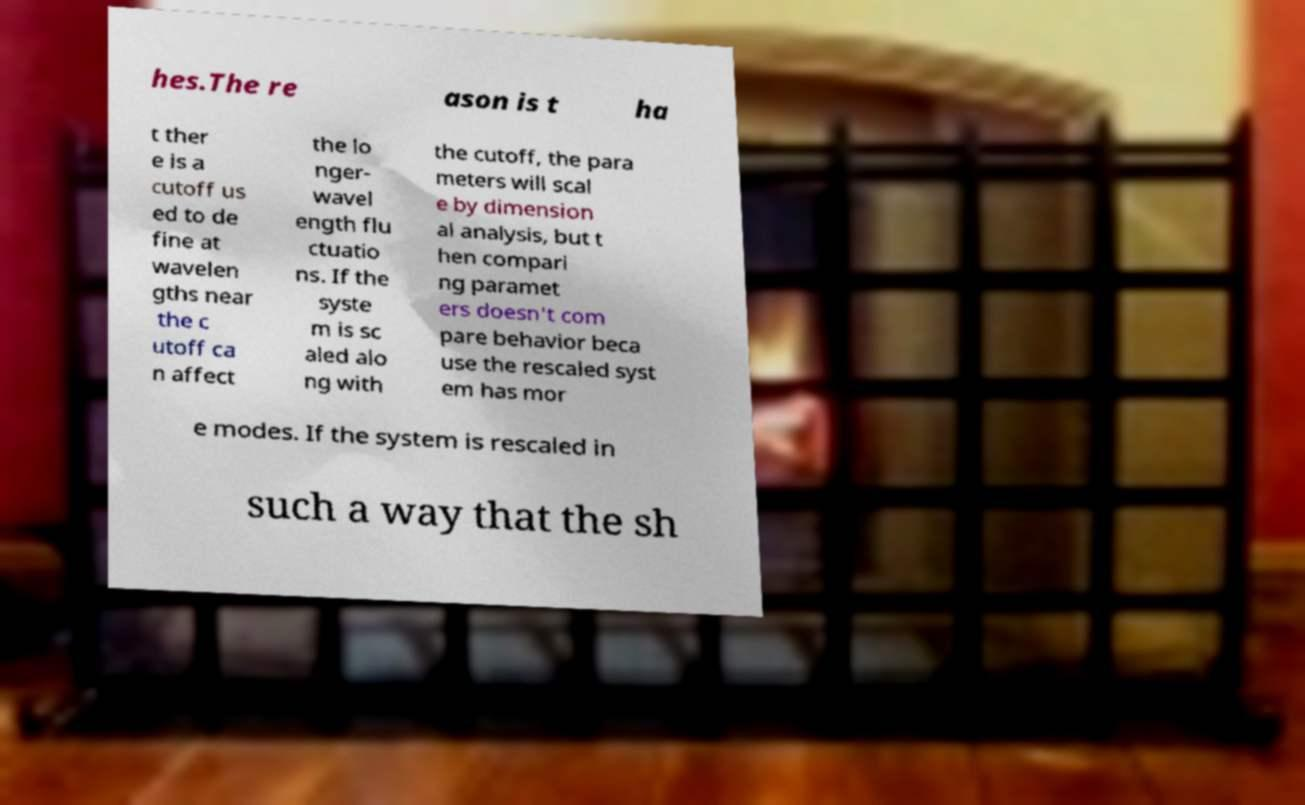Please read and relay the text visible in this image. What does it say? hes.The re ason is t ha t ther e is a cutoff us ed to de fine at wavelen gths near the c utoff ca n affect the lo nger- wavel ength flu ctuatio ns. If the syste m is sc aled alo ng with the cutoff, the para meters will scal e by dimension al analysis, but t hen compari ng paramet ers doesn't com pare behavior beca use the rescaled syst em has mor e modes. If the system is rescaled in such a way that the sh 